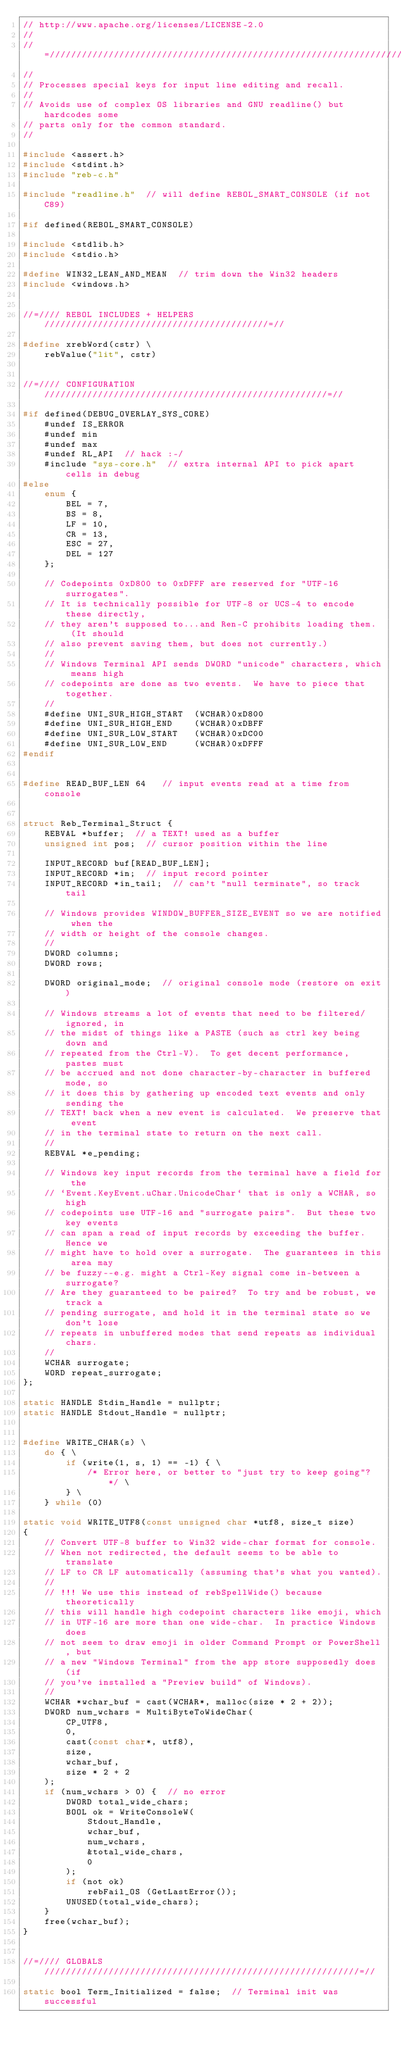<code> <loc_0><loc_0><loc_500><loc_500><_C_>// http://www.apache.org/licenses/LICENSE-2.0
//
//=////////////////////////////////////////////////////////////////////////=//
//
// Processes special keys for input line editing and recall.
//
// Avoids use of complex OS libraries and GNU readline() but hardcodes some
// parts only for the common standard.
//

#include <assert.h>
#include <stdint.h>
#include "reb-c.h"

#include "readline.h"  // will define REBOL_SMART_CONSOLE (if not C89)

#if defined(REBOL_SMART_CONSOLE)

#include <stdlib.h>
#include <stdio.h>

#define WIN32_LEAN_AND_MEAN  // trim down the Win32 headers
#include <windows.h>


//=//// REBOL INCLUDES + HELPERS //////////////////////////////////////////=//

#define xrebWord(cstr) \
    rebValue("lit", cstr)


//=//// CONFIGURATION /////////////////////////////////////////////////////=//

#if defined(DEBUG_OVERLAY_SYS_CORE)
    #undef IS_ERROR
    #undef min
    #undef max
    #undef RL_API  // hack :-/
    #include "sys-core.h"  // extra internal API to pick apart cells in debug
#else
    enum {
        BEL = 7,
        BS = 8,
        LF = 10,
        CR = 13,
        ESC = 27,
        DEL = 127
    };

    // Codepoints 0xD800 to 0xDFFF are reserved for "UTF-16 surrogates".
    // It is technically possible for UTF-8 or UCS-4 to encode these directly,
    // they aren't supposed to...and Ren-C prohibits loading them.  (It should
    // also prevent saving them, but does not currently.)
    //
    // Windows Terminal API sends DWORD "unicode" characters, which means high
    // codepoints are done as two events.  We have to piece that together.
    //
    #define UNI_SUR_HIGH_START  (WCHAR)0xD800
    #define UNI_SUR_HIGH_END    (WCHAR)0xDBFF
    #define UNI_SUR_LOW_START   (WCHAR)0xDC00
    #define UNI_SUR_LOW_END     (WCHAR)0xDFFF
#endif


#define READ_BUF_LEN 64   // input events read at a time from console


struct Reb_Terminal_Struct {
    REBVAL *buffer;  // a TEXT! used as a buffer
    unsigned int pos;  // cursor position within the line

    INPUT_RECORD buf[READ_BUF_LEN];
    INPUT_RECORD *in;  // input record pointer
    INPUT_RECORD *in_tail;  // can't "null terminate", so track tail

    // Windows provides WINDOW_BUFFER_SIZE_EVENT so we are notified when the
    // width or height of the console changes.
    //
    DWORD columns;
    DWORD rows;

    DWORD original_mode;  // original console mode (restore on exit)

    // Windows streams a lot of events that need to be filtered/ignored, in
    // the midst of things like a PASTE (such as ctrl key being down and
    // repeated from the Ctrl-V).  To get decent performance, pastes must
    // be accrued and not done character-by-character in buffered mode, so
    // it does this by gathering up encoded text events and only sending the
    // TEXT! back when a new event is calculated.  We preserve that event
    // in the terminal state to return on the next call.
    //
    REBVAL *e_pending;

    // Windows key input records from the terminal have a field for the
    // `Event.KeyEvent.uChar.UnicodeChar` that is only a WCHAR, so high
    // codepoints use UTF-16 and "surrogate pairs".  But these two key events
    // can span a read of input records by exceeding the buffer.  Hence we
    // might have to hold over a surrogate.  The guarantees in this area may
    // be fuzzy--e.g. might a Ctrl-Key signal come in-between a surrogate?
    // Are they guaranteed to be paired?  To try and be robust, we track a
    // pending surrogate, and hold it in the terminal state so we don't lose
    // repeats in unbuffered modes that send repeats as individual chars.
    //
    WCHAR surrogate;
    WORD repeat_surrogate;
};

static HANDLE Stdin_Handle = nullptr;
static HANDLE Stdout_Handle = nullptr;


#define WRITE_CHAR(s) \
    do { \
        if (write(1, s, 1) == -1) { \
            /* Error here, or better to "just try to keep going"? */ \
        } \
    } while (0)

static void WRITE_UTF8(const unsigned char *utf8, size_t size)
{
    // Convert UTF-8 buffer to Win32 wide-char format for console.
    // When not redirected, the default seems to be able to translate
    // LF to CR LF automatically (assuming that's what you wanted).
    //
    // !!! We use this instead of rebSpellWide() because theoretically
    // this will handle high codepoint characters like emoji, which
    // in UTF-16 are more than one wide-char.  In practice Windows does
    // not seem to draw emoji in older Command Prompt or PowerShell, but
    // a new "Windows Terminal" from the app store supposedly does (if
    // you've installed a "Preview build" of Windows).
    //
    WCHAR *wchar_buf = cast(WCHAR*, malloc(size * 2 + 2));
    DWORD num_wchars = MultiByteToWideChar(
        CP_UTF8,
        0,
        cast(const char*, utf8),
        size,
        wchar_buf,
        size * 2 + 2
    );
    if (num_wchars > 0) {  // no error
        DWORD total_wide_chars;
        BOOL ok = WriteConsoleW(
            Stdout_Handle,
            wchar_buf,
            num_wchars,
            &total_wide_chars,
            0
        );
        if (not ok)
            rebFail_OS (GetLastError());
        UNUSED(total_wide_chars);
    }
    free(wchar_buf);
}


//=//// GLOBALS ///////////////////////////////////////////////////////////=//

static bool Term_Initialized = false;  // Terminal init was successful

</code> 